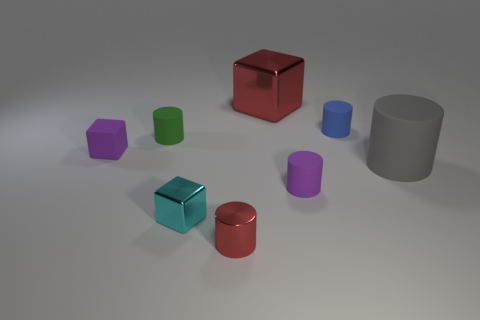Is the shape of the cyan metal thing the same as the red metallic thing that is in front of the tiny blue rubber thing?
Your response must be concise. No. Is the number of small matte cylinders in front of the tiny red thing greater than the number of purple cubes that are on the right side of the big red cube?
Give a very brief answer. No. Are there any other things that are the same color as the big metallic thing?
Your answer should be very brief. Yes. There is a green thing that is to the left of the large cylinder that is behind the metal cylinder; are there any green cylinders in front of it?
Offer a terse response. No. There is a red shiny object behind the tiny blue cylinder; is its shape the same as the green thing?
Give a very brief answer. No. Are there fewer small matte cylinders on the right side of the tiny purple rubber cylinder than cubes in front of the big metallic object?
Your response must be concise. Yes. What is the material of the tiny green thing?
Keep it short and to the point. Rubber. Is the color of the shiny cylinder the same as the tiny cube that is to the left of the green object?
Make the answer very short. No. There is a large gray thing; how many gray rubber objects are in front of it?
Offer a terse response. 0. Is the number of small green matte things behind the small blue cylinder less than the number of small green objects?
Ensure brevity in your answer.  Yes. 